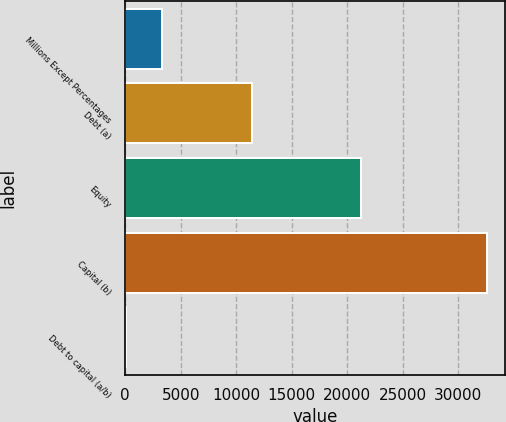Convert chart. <chart><loc_0><loc_0><loc_500><loc_500><bar_chart><fcel>Millions Except Percentages<fcel>Debt (a)<fcel>Equity<fcel>Capital (b)<fcel>Debt to capital (a/b)<nl><fcel>3291.7<fcel>11413<fcel>21189<fcel>32602<fcel>35<nl></chart> 